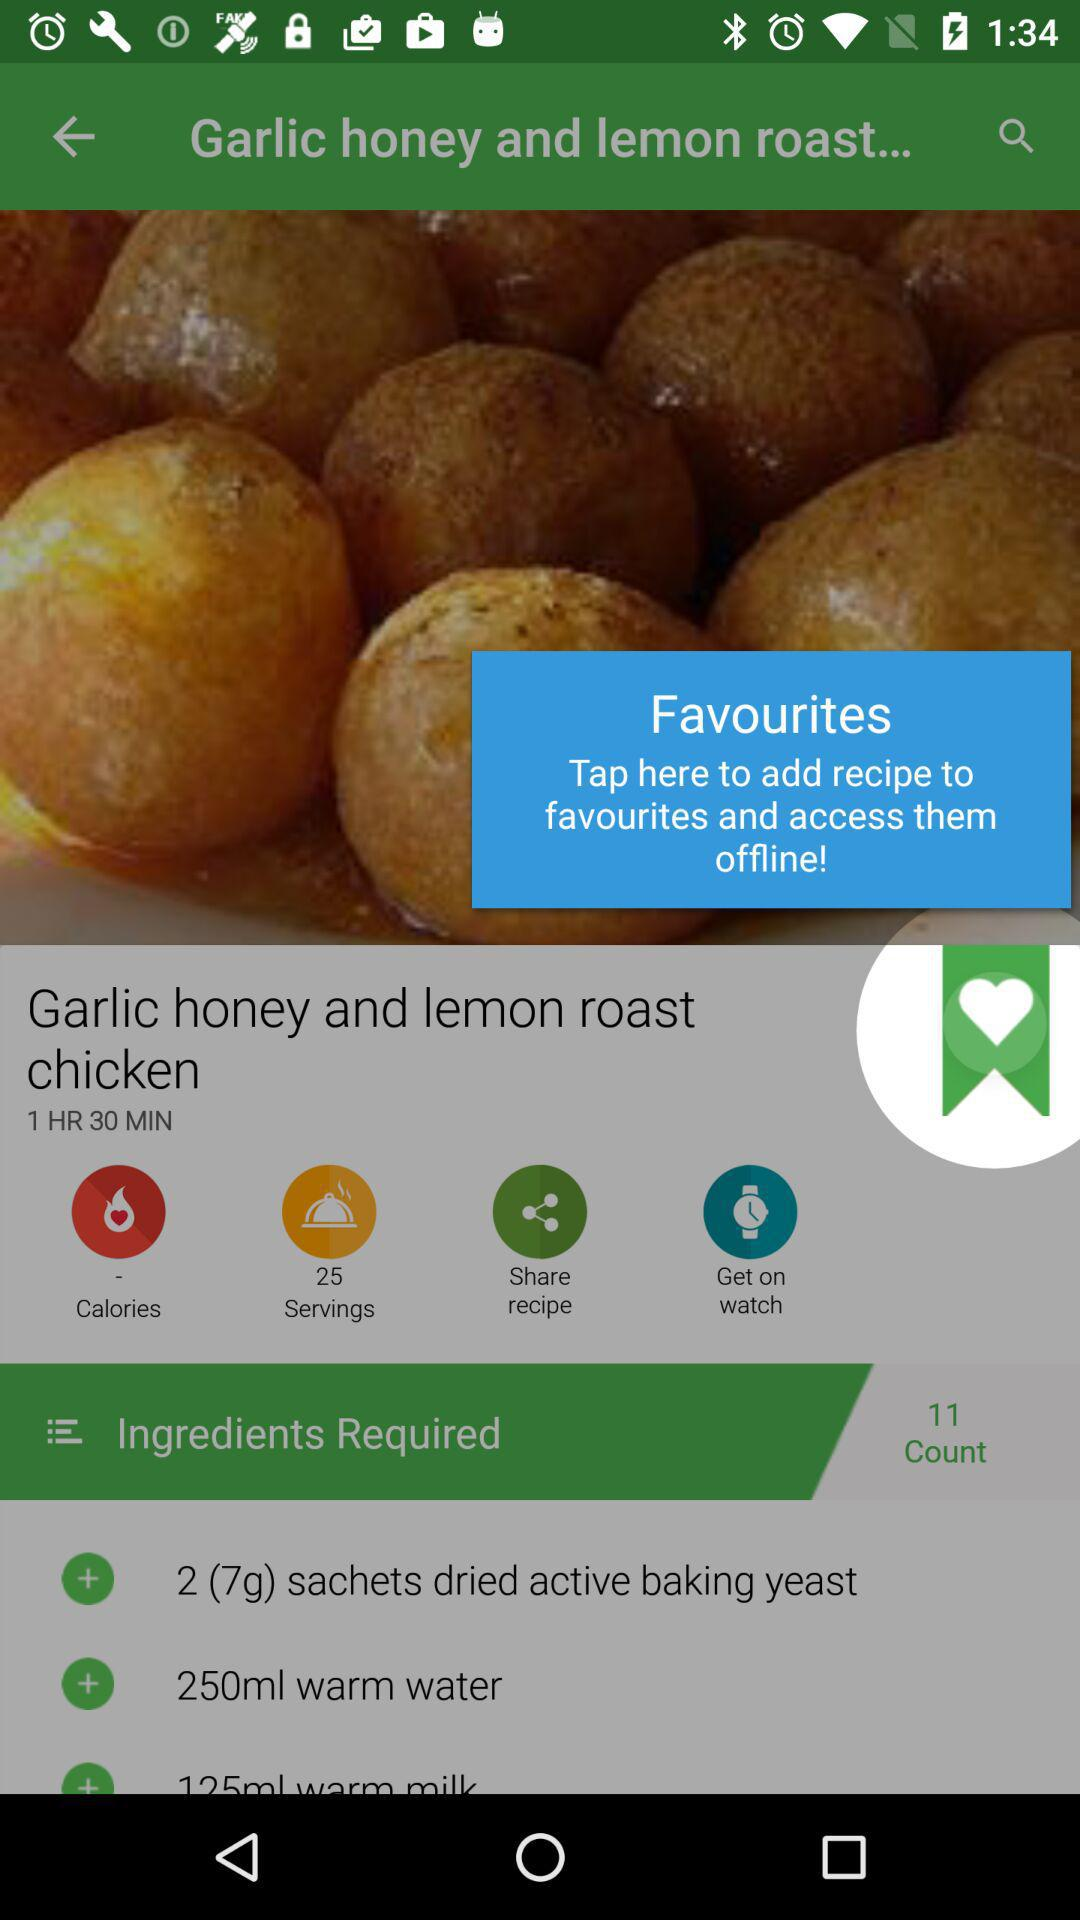What is the time to prepare the "Garlic honey and lemon roast chicken"? The time to prepare the "Garlic honey and lemon roast chicken" is 1 hour and 30 minutes. 